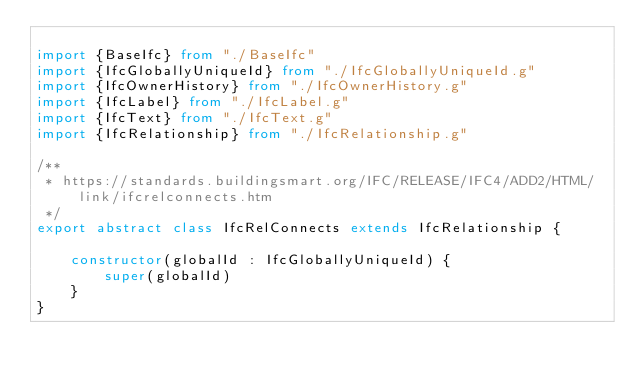Convert code to text. <code><loc_0><loc_0><loc_500><loc_500><_TypeScript_>
import {BaseIfc} from "./BaseIfc"
import {IfcGloballyUniqueId} from "./IfcGloballyUniqueId.g"
import {IfcOwnerHistory} from "./IfcOwnerHistory.g"
import {IfcLabel} from "./IfcLabel.g"
import {IfcText} from "./IfcText.g"
import {IfcRelationship} from "./IfcRelationship.g"

/**
 * https://standards.buildingsmart.org/IFC/RELEASE/IFC4/ADD2/HTML/link/ifcrelconnects.htm
 */
export abstract class IfcRelConnects extends IfcRelationship {

    constructor(globalId : IfcGloballyUniqueId) {
        super(globalId)
    }
}</code> 